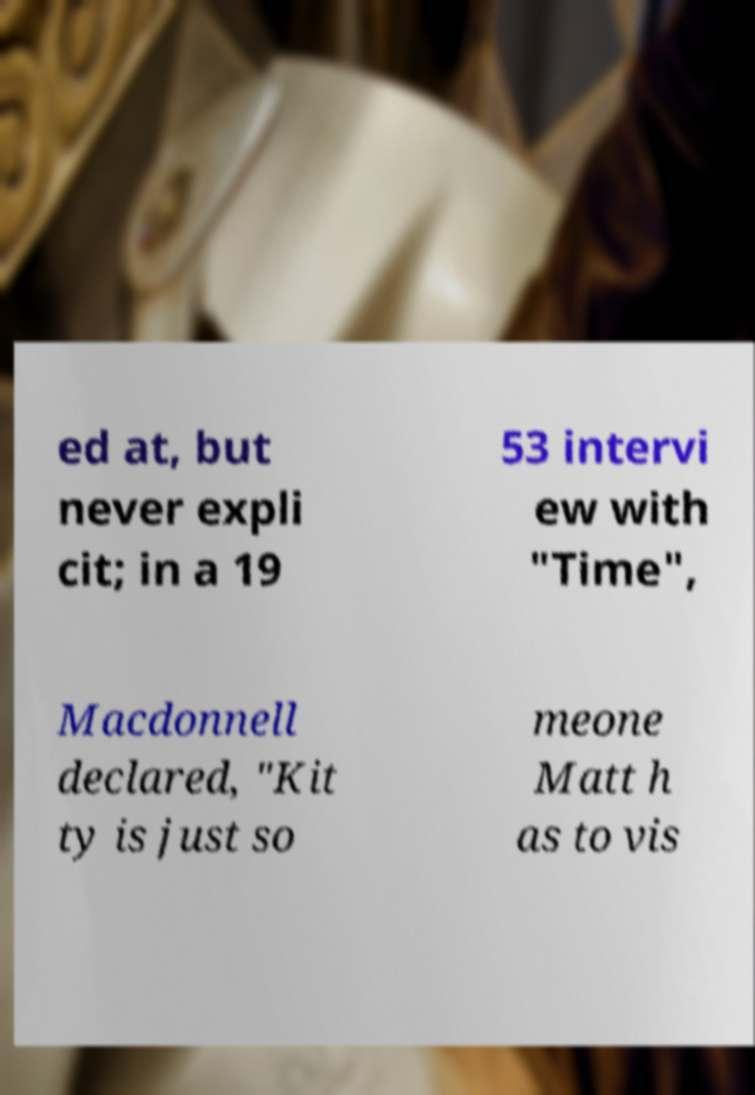Can you read and provide the text displayed in the image?This photo seems to have some interesting text. Can you extract and type it out for me? ed at, but never expli cit; in a 19 53 intervi ew with "Time", Macdonnell declared, "Kit ty is just so meone Matt h as to vis 